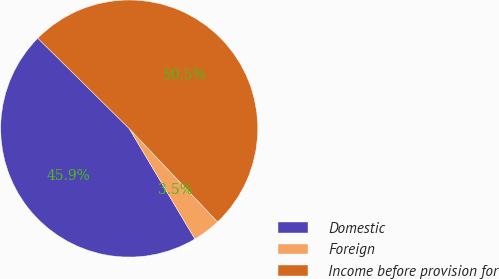<chart> <loc_0><loc_0><loc_500><loc_500><pie_chart><fcel>Domestic<fcel>Foreign<fcel>Income before provision for<nl><fcel>45.94%<fcel>3.52%<fcel>50.53%<nl></chart> 